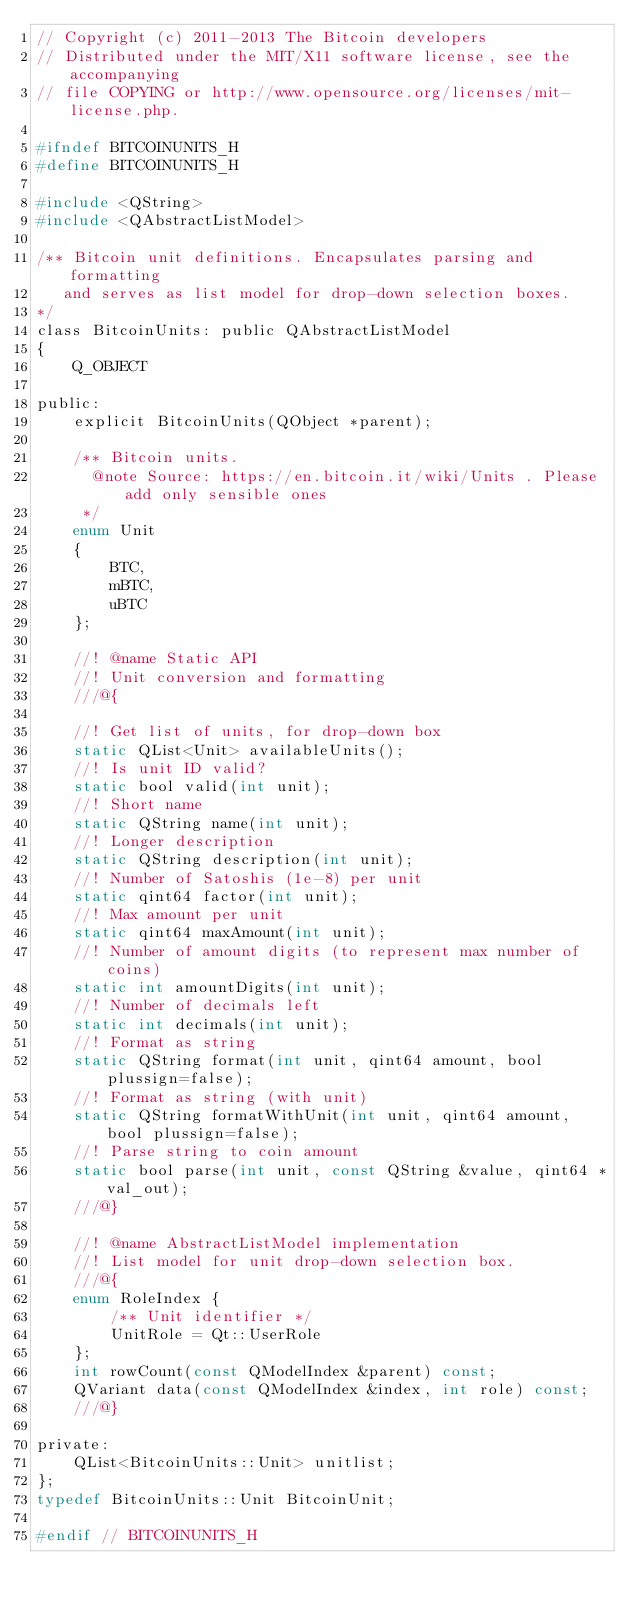Convert code to text. <code><loc_0><loc_0><loc_500><loc_500><_C_>// Copyright (c) 2011-2013 The Bitcoin developers
// Distributed under the MIT/X11 software license, see the accompanying
// file COPYING or http://www.opensource.org/licenses/mit-license.php.

#ifndef BITCOINUNITS_H
#define BITCOINUNITS_H

#include <QString>
#include <QAbstractListModel>

/** Bitcoin unit definitions. Encapsulates parsing and formatting
   and serves as list model for drop-down selection boxes.
*/
class BitcoinUnits: public QAbstractListModel
{
    Q_OBJECT

public:
    explicit BitcoinUnits(QObject *parent);

    /** Bitcoin units.
      @note Source: https://en.bitcoin.it/wiki/Units . Please add only sensible ones
     */
    enum Unit
    {
        BTC,
        mBTC,
        uBTC
    };

    //! @name Static API
    //! Unit conversion and formatting
    ///@{

    //! Get list of units, for drop-down box
    static QList<Unit> availableUnits();
    //! Is unit ID valid?
    static bool valid(int unit);
    //! Short name
    static QString name(int unit);
    //! Longer description
    static QString description(int unit);
    //! Number of Satoshis (1e-8) per unit
    static qint64 factor(int unit);
    //! Max amount per unit
    static qint64 maxAmount(int unit);
    //! Number of amount digits (to represent max number of coins)
    static int amountDigits(int unit);
    //! Number of decimals left
    static int decimals(int unit);
    //! Format as string
    static QString format(int unit, qint64 amount, bool plussign=false);
    //! Format as string (with unit)
    static QString formatWithUnit(int unit, qint64 amount, bool plussign=false);
    //! Parse string to coin amount
    static bool parse(int unit, const QString &value, qint64 *val_out);
    ///@}

    //! @name AbstractListModel implementation
    //! List model for unit drop-down selection box.
    ///@{
    enum RoleIndex {
        /** Unit identifier */
        UnitRole = Qt::UserRole
    };
    int rowCount(const QModelIndex &parent) const;
    QVariant data(const QModelIndex &index, int role) const;
    ///@}

private:
    QList<BitcoinUnits::Unit> unitlist;
};
typedef BitcoinUnits::Unit BitcoinUnit;

#endif // BITCOINUNITS_H
</code> 